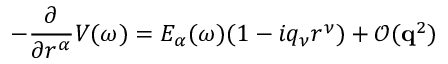Convert formula to latex. <formula><loc_0><loc_0><loc_500><loc_500>- \frac { \partial } { \partial r ^ { \alpha } } V ( \omega ) = E _ { \alpha } ( \omega ) ( 1 - i q _ { \nu } r ^ { \nu } ) + \mathcal { O } ( q ^ { 2 } )</formula> 